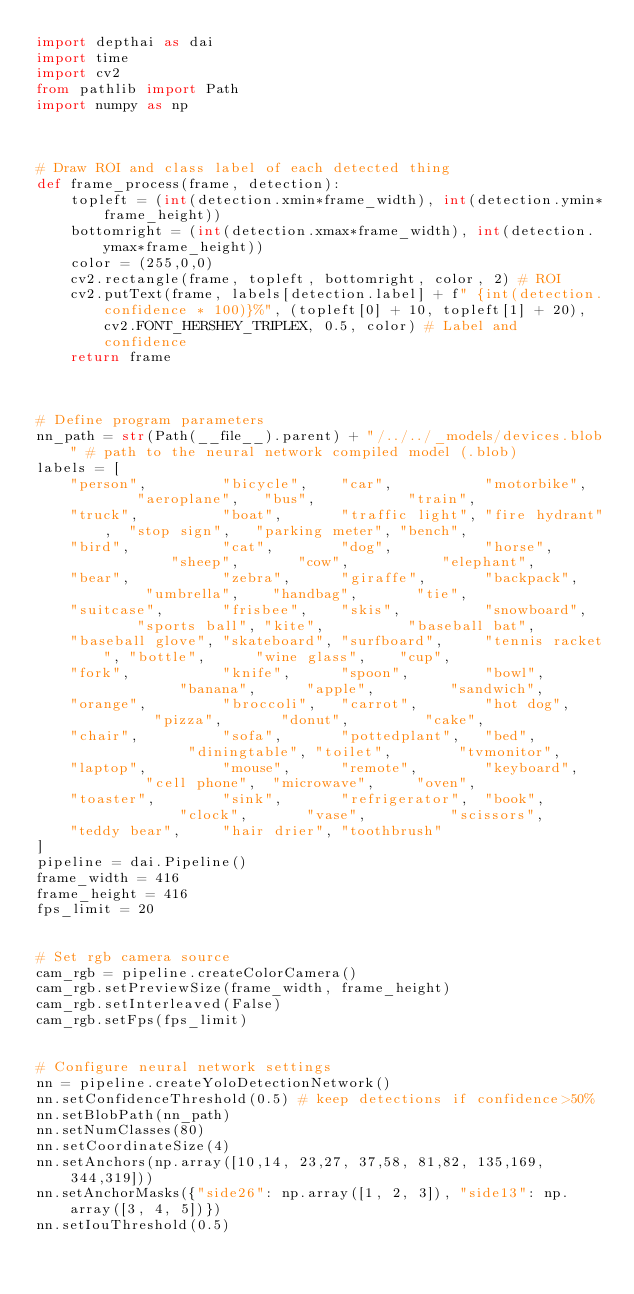Convert code to text. <code><loc_0><loc_0><loc_500><loc_500><_Python_>import depthai as dai
import time
import cv2
from pathlib import Path
import numpy as np



# Draw ROI and class label of each detected thing
def frame_process(frame, detection):
    topleft = (int(detection.xmin*frame_width), int(detection.ymin*frame_height))
    bottomright = (int(detection.xmax*frame_width), int(detection.ymax*frame_height))
    color = (255,0,0)
    cv2.rectangle(frame, topleft, bottomright, color, 2) # ROI
    cv2.putText(frame, labels[detection.label] + f" {int(detection.confidence * 100)}%", (topleft[0] + 10, topleft[1] + 20), cv2.FONT_HERSHEY_TRIPLEX, 0.5, color) # Label and confidence
    return frame



# Define program parameters
nn_path = str(Path(__file__).parent) + "/../../_models/devices.blob" # path to the neural network compiled model (.blob)
labels = [
    "person",         "bicycle",    "car",           "motorbike",     "aeroplane",   "bus",           "train",
    "truck",          "boat",       "traffic light", "fire hydrant",  "stop sign",   "parking meter", "bench",
    "bird",           "cat",        "dog",           "horse",         "sheep",       "cow",           "elephant",
    "bear",           "zebra",      "giraffe",       "backpack",      "umbrella",    "handbag",       "tie",
    "suitcase",       "frisbee",    "skis",          "snowboard",     "sports ball", "kite",          "baseball bat",
    "baseball glove", "skateboard", "surfboard",     "tennis racket", "bottle",      "wine glass",    "cup",
    "fork",           "knife",      "spoon",         "bowl",          "banana",      "apple",         "sandwich",
    "orange",         "broccoli",   "carrot",        "hot dog",       "pizza",       "donut",         "cake",
    "chair",          "sofa",       "pottedplant",   "bed",           "diningtable", "toilet",        "tvmonitor",
    "laptop",         "mouse",      "remote",        "keyboard",      "cell phone",  "microwave",     "oven",
    "toaster",        "sink",       "refrigerator",  "book",          "clock",       "vase",          "scissors",
    "teddy bear",     "hair drier", "toothbrush"
]
pipeline = dai.Pipeline()
frame_width = 416
frame_height = 416
fps_limit = 20


# Set rgb camera source
cam_rgb = pipeline.createColorCamera()
cam_rgb.setPreviewSize(frame_width, frame_height)
cam_rgb.setInterleaved(False)
cam_rgb.setFps(fps_limit)


# Configure neural network settings
nn = pipeline.createYoloDetectionNetwork()
nn.setConfidenceThreshold(0.5) # keep detections if confidence>50%
nn.setBlobPath(nn_path)
nn.setNumClasses(80)
nn.setCoordinateSize(4)
nn.setAnchors(np.array([10,14, 23,27, 37,58, 81,82, 135,169, 344,319]))
nn.setAnchorMasks({"side26": np.array([1, 2, 3]), "side13": np.array([3, 4, 5])})
nn.setIouThreshold(0.5)</code> 